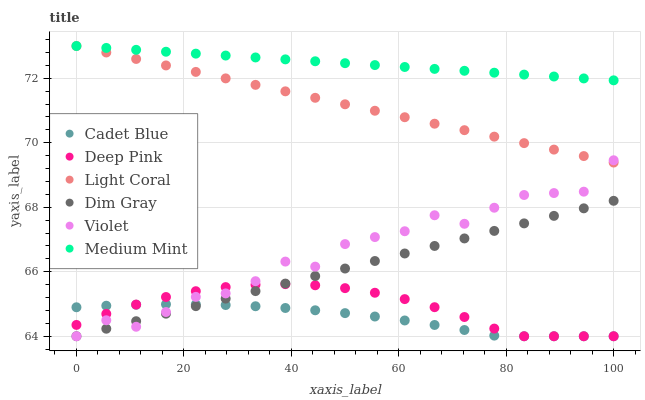Does Cadet Blue have the minimum area under the curve?
Answer yes or no. Yes. Does Medium Mint have the maximum area under the curve?
Answer yes or no. Yes. Does Dim Gray have the minimum area under the curve?
Answer yes or no. No. Does Dim Gray have the maximum area under the curve?
Answer yes or no. No. Is Dim Gray the smoothest?
Answer yes or no. Yes. Is Violet the roughest?
Answer yes or no. Yes. Is Deep Pink the smoothest?
Answer yes or no. No. Is Deep Pink the roughest?
Answer yes or no. No. Does Dim Gray have the lowest value?
Answer yes or no. Yes. Does Light Coral have the lowest value?
Answer yes or no. No. Does Light Coral have the highest value?
Answer yes or no. Yes. Does Dim Gray have the highest value?
Answer yes or no. No. Is Dim Gray less than Medium Mint?
Answer yes or no. Yes. Is Light Coral greater than Cadet Blue?
Answer yes or no. Yes. Does Deep Pink intersect Violet?
Answer yes or no. Yes. Is Deep Pink less than Violet?
Answer yes or no. No. Is Deep Pink greater than Violet?
Answer yes or no. No. Does Dim Gray intersect Medium Mint?
Answer yes or no. No. 